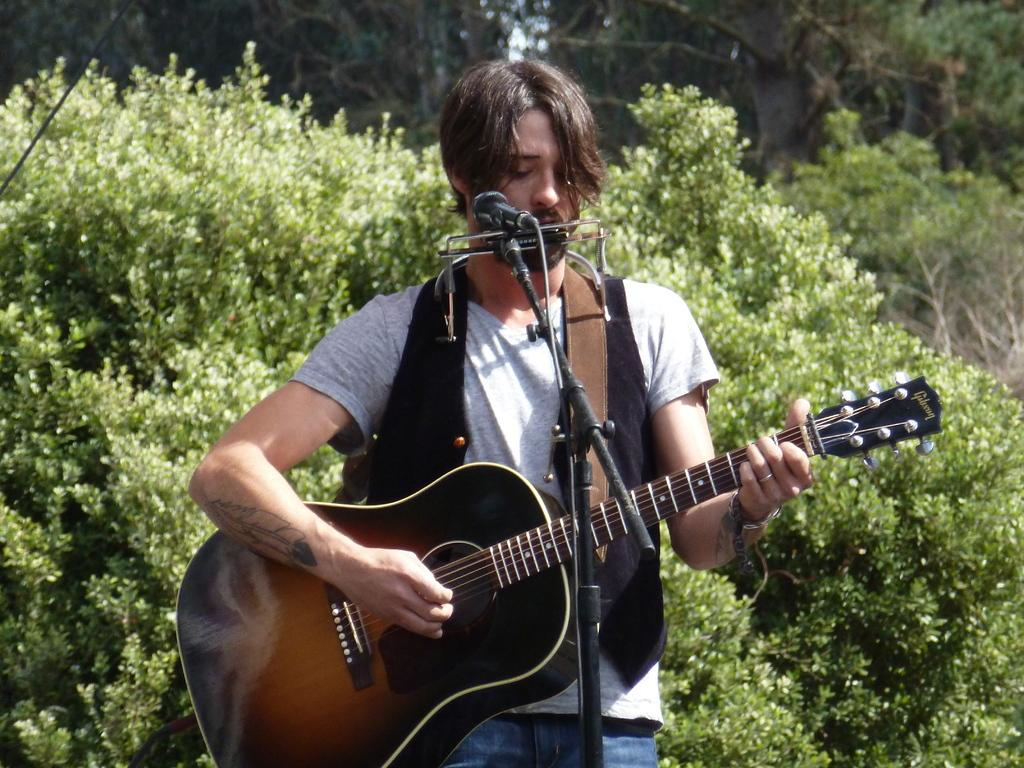What is the man in the image doing? The man is playing the guitar and singing. What instrument is the man holding in the image? The man is holding a guitar in the image. Is there any equipment present that might be used for amplifying the man's voice? Yes, there is a microphone in the image. What can be seen in the background of the image? There is a tree in the background of the image. What type of coal is visible in the image? There is no coal present in the image. Is there a glass of water on the table in the image? The provided facts do not mention a table or a glass of water, so we cannot determine if one is present. 